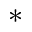<formula> <loc_0><loc_0><loc_500><loc_500>{ ^ { * } }</formula> 